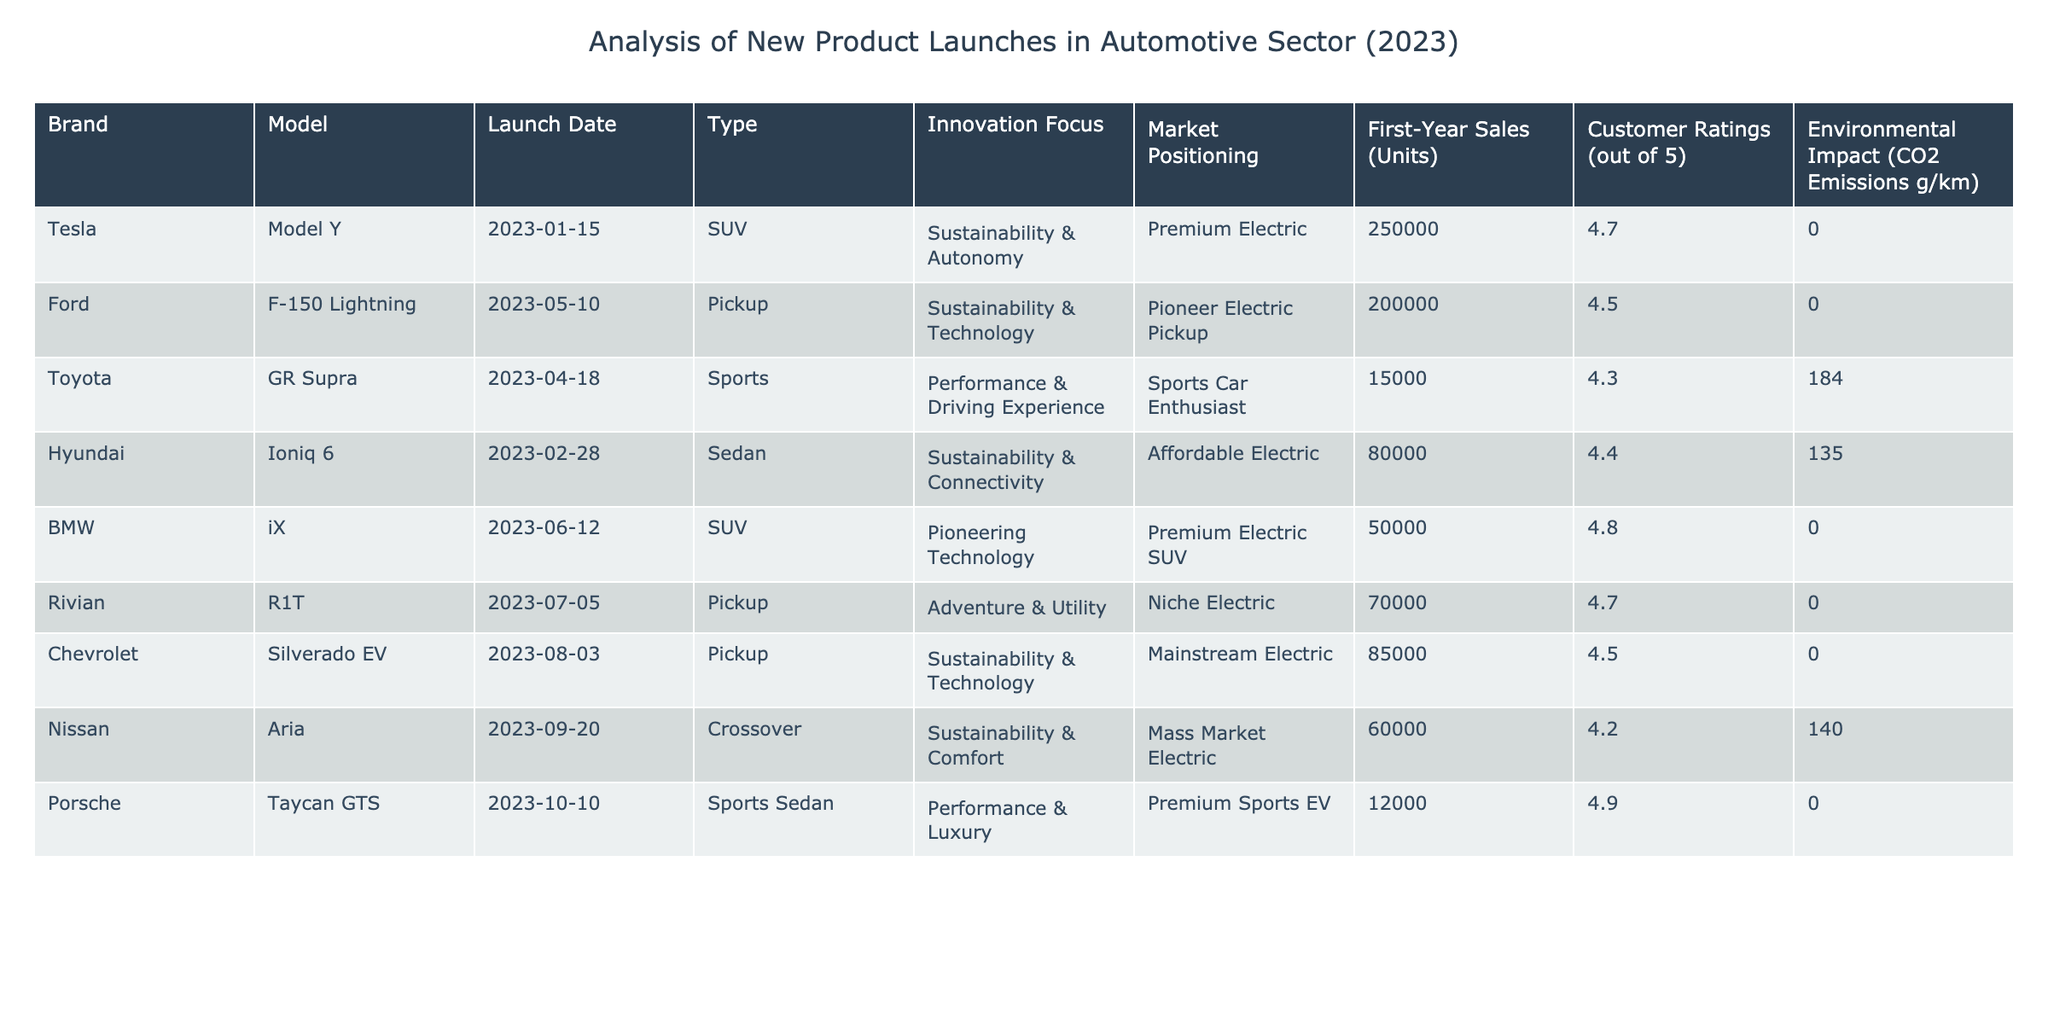What is the highest customer rating among the new products? The highest customer rating in the table is found by looking across the Customer Ratings column. The model with the highest rating is the Porsche Taycan GTS, which has a customer rating of 4.9.
Answer: 4.9 Which automotive brand launched a sports car in 2023? The table lists various brands and models, and by checking the Type column, we see that the Toyota GR Supra is categorized as a Sports car, confirming it was launched by Toyota in 2023.
Answer: Toyota What is the total first-year sales (units) of electric SUVs launched in 2023? We identify electric SUVs by filtering the table for models labeled as SUVs and whose Innovation Focus relates to electric. The relevant models are the Tesla Model Y and BMW iX, with first-year sales of 250,000 and 50,000 units, respectively. Summing these gives 250,000 + 50,000 = 300,000 units.
Answer: 300000 Is the Ford F-150 Lightning's environmental impact lower than that of the Nissan Aria? The environmental impacts are given in the CO2 Emissions column. Ford F-150 Lightning has an environmental impact of 0 g/km, whereas the Nissan Aria has 140 g/km. As 0 is less than 140, the statement is true, making the Ford model's impact lower.
Answer: Yes What percentage of first-year sales were achieved by the Tesla Model Y compared to the total first-year sales of all models combined? First, we calculate the total first-year sales by summing all values in the First-Year Sales column: 250000 (Tesla) + 200000 (Ford) + 15000 (Toyota) + 80000 (Hyundai) + 50000 (BMW) + 70000 (Rivian) + 85000 (Chevrolet) + 60000 (Nissan) + 12000 (Porsche) = 683000 units. The percentage for Tesla is then (250000 / 683000) * 100 ≈ 36.6%.
Answer: 36.6% How many models have a first-year sales figure greater than 80,000 units? By examining the First-Year Sales column, we see that the models with sales greater than 80,000 are the Tesla Model Y (250,000), Ford F-150 Lightning (200,000), and Chevrolet Silverado EV (85,000), totaling three models.
Answer: 3 